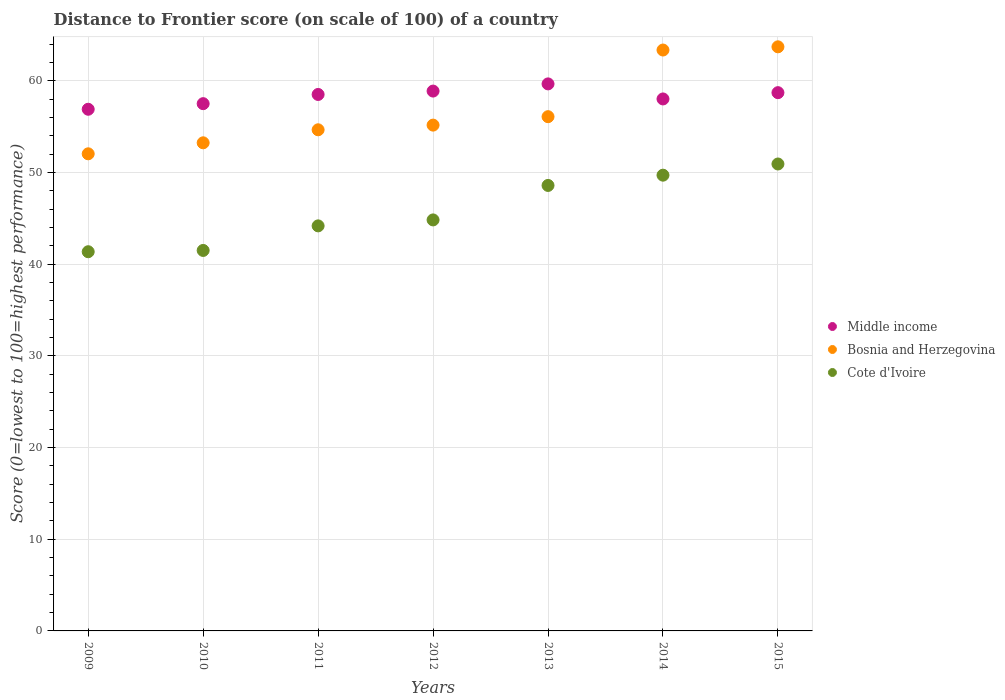Is the number of dotlines equal to the number of legend labels?
Provide a short and direct response. Yes. What is the distance to frontier score of in Middle income in 2010?
Keep it short and to the point. 57.51. Across all years, what is the maximum distance to frontier score of in Bosnia and Herzegovina?
Provide a succinct answer. 63.71. Across all years, what is the minimum distance to frontier score of in Middle income?
Your answer should be very brief. 56.9. In which year was the distance to frontier score of in Cote d'Ivoire maximum?
Provide a succinct answer. 2015. In which year was the distance to frontier score of in Middle income minimum?
Ensure brevity in your answer.  2009. What is the total distance to frontier score of in Cote d'Ivoire in the graph?
Offer a very short reply. 321.1. What is the difference between the distance to frontier score of in Middle income in 2009 and that in 2015?
Make the answer very short. -1.81. What is the difference between the distance to frontier score of in Cote d'Ivoire in 2015 and the distance to frontier score of in Bosnia and Herzegovina in 2013?
Your response must be concise. -5.16. What is the average distance to frontier score of in Middle income per year?
Make the answer very short. 58.32. What is the ratio of the distance to frontier score of in Bosnia and Herzegovina in 2010 to that in 2011?
Make the answer very short. 0.97. Is the difference between the distance to frontier score of in Cote d'Ivoire in 2009 and 2014 greater than the difference between the distance to frontier score of in Bosnia and Herzegovina in 2009 and 2014?
Offer a very short reply. Yes. What is the difference between the highest and the second highest distance to frontier score of in Cote d'Ivoire?
Your response must be concise. 1.22. What is the difference between the highest and the lowest distance to frontier score of in Cote d'Ivoire?
Make the answer very short. 9.57. In how many years, is the distance to frontier score of in Cote d'Ivoire greater than the average distance to frontier score of in Cote d'Ivoire taken over all years?
Give a very brief answer. 3. Is the sum of the distance to frontier score of in Cote d'Ivoire in 2009 and 2015 greater than the maximum distance to frontier score of in Bosnia and Herzegovina across all years?
Your response must be concise. Yes. Is it the case that in every year, the sum of the distance to frontier score of in Middle income and distance to frontier score of in Cote d'Ivoire  is greater than the distance to frontier score of in Bosnia and Herzegovina?
Your response must be concise. Yes. Is the distance to frontier score of in Middle income strictly greater than the distance to frontier score of in Bosnia and Herzegovina over the years?
Ensure brevity in your answer.  No. Is the distance to frontier score of in Middle income strictly less than the distance to frontier score of in Bosnia and Herzegovina over the years?
Ensure brevity in your answer.  No. How many dotlines are there?
Offer a terse response. 3. How many years are there in the graph?
Give a very brief answer. 7. What is the difference between two consecutive major ticks on the Y-axis?
Ensure brevity in your answer.  10. Does the graph contain any zero values?
Provide a short and direct response. No. Where does the legend appear in the graph?
Offer a very short reply. Center right. How many legend labels are there?
Ensure brevity in your answer.  3. What is the title of the graph?
Offer a very short reply. Distance to Frontier score (on scale of 100) of a country. What is the label or title of the X-axis?
Offer a very short reply. Years. What is the label or title of the Y-axis?
Provide a succinct answer. Score (0=lowest to 100=highest performance). What is the Score (0=lowest to 100=highest performance) in Middle income in 2009?
Keep it short and to the point. 56.9. What is the Score (0=lowest to 100=highest performance) in Bosnia and Herzegovina in 2009?
Offer a very short reply. 52.04. What is the Score (0=lowest to 100=highest performance) of Cote d'Ivoire in 2009?
Your response must be concise. 41.36. What is the Score (0=lowest to 100=highest performance) in Middle income in 2010?
Offer a terse response. 57.51. What is the Score (0=lowest to 100=highest performance) in Bosnia and Herzegovina in 2010?
Keep it short and to the point. 53.24. What is the Score (0=lowest to 100=highest performance) in Cote d'Ivoire in 2010?
Your response must be concise. 41.5. What is the Score (0=lowest to 100=highest performance) of Middle income in 2011?
Provide a succinct answer. 58.51. What is the Score (0=lowest to 100=highest performance) in Bosnia and Herzegovina in 2011?
Make the answer very short. 54.66. What is the Score (0=lowest to 100=highest performance) in Cote d'Ivoire in 2011?
Keep it short and to the point. 44.18. What is the Score (0=lowest to 100=highest performance) of Middle income in 2012?
Make the answer very short. 58.88. What is the Score (0=lowest to 100=highest performance) in Bosnia and Herzegovina in 2012?
Your answer should be very brief. 55.17. What is the Score (0=lowest to 100=highest performance) of Cote d'Ivoire in 2012?
Offer a terse response. 44.83. What is the Score (0=lowest to 100=highest performance) of Middle income in 2013?
Your answer should be very brief. 59.67. What is the Score (0=lowest to 100=highest performance) of Bosnia and Herzegovina in 2013?
Offer a terse response. 56.09. What is the Score (0=lowest to 100=highest performance) of Cote d'Ivoire in 2013?
Your answer should be compact. 48.59. What is the Score (0=lowest to 100=highest performance) of Middle income in 2014?
Keep it short and to the point. 58.02. What is the Score (0=lowest to 100=highest performance) of Bosnia and Herzegovina in 2014?
Keep it short and to the point. 63.36. What is the Score (0=lowest to 100=highest performance) in Cote d'Ivoire in 2014?
Provide a short and direct response. 49.71. What is the Score (0=lowest to 100=highest performance) of Middle income in 2015?
Ensure brevity in your answer.  58.71. What is the Score (0=lowest to 100=highest performance) of Bosnia and Herzegovina in 2015?
Offer a very short reply. 63.71. What is the Score (0=lowest to 100=highest performance) in Cote d'Ivoire in 2015?
Your response must be concise. 50.93. Across all years, what is the maximum Score (0=lowest to 100=highest performance) of Middle income?
Offer a very short reply. 59.67. Across all years, what is the maximum Score (0=lowest to 100=highest performance) of Bosnia and Herzegovina?
Offer a very short reply. 63.71. Across all years, what is the maximum Score (0=lowest to 100=highest performance) of Cote d'Ivoire?
Your answer should be very brief. 50.93. Across all years, what is the minimum Score (0=lowest to 100=highest performance) of Middle income?
Keep it short and to the point. 56.9. Across all years, what is the minimum Score (0=lowest to 100=highest performance) of Bosnia and Herzegovina?
Offer a very short reply. 52.04. Across all years, what is the minimum Score (0=lowest to 100=highest performance) of Cote d'Ivoire?
Offer a very short reply. 41.36. What is the total Score (0=lowest to 100=highest performance) in Middle income in the graph?
Give a very brief answer. 408.21. What is the total Score (0=lowest to 100=highest performance) of Bosnia and Herzegovina in the graph?
Your answer should be compact. 398.27. What is the total Score (0=lowest to 100=highest performance) of Cote d'Ivoire in the graph?
Offer a terse response. 321.1. What is the difference between the Score (0=lowest to 100=highest performance) of Middle income in 2009 and that in 2010?
Keep it short and to the point. -0.61. What is the difference between the Score (0=lowest to 100=highest performance) in Cote d'Ivoire in 2009 and that in 2010?
Offer a terse response. -0.14. What is the difference between the Score (0=lowest to 100=highest performance) of Middle income in 2009 and that in 2011?
Your answer should be very brief. -1.61. What is the difference between the Score (0=lowest to 100=highest performance) of Bosnia and Herzegovina in 2009 and that in 2011?
Provide a short and direct response. -2.62. What is the difference between the Score (0=lowest to 100=highest performance) of Cote d'Ivoire in 2009 and that in 2011?
Your answer should be very brief. -2.82. What is the difference between the Score (0=lowest to 100=highest performance) of Middle income in 2009 and that in 2012?
Offer a terse response. -1.98. What is the difference between the Score (0=lowest to 100=highest performance) in Bosnia and Herzegovina in 2009 and that in 2012?
Make the answer very short. -3.13. What is the difference between the Score (0=lowest to 100=highest performance) in Cote d'Ivoire in 2009 and that in 2012?
Ensure brevity in your answer.  -3.47. What is the difference between the Score (0=lowest to 100=highest performance) in Middle income in 2009 and that in 2013?
Keep it short and to the point. -2.77. What is the difference between the Score (0=lowest to 100=highest performance) of Bosnia and Herzegovina in 2009 and that in 2013?
Your answer should be compact. -4.05. What is the difference between the Score (0=lowest to 100=highest performance) in Cote d'Ivoire in 2009 and that in 2013?
Your answer should be very brief. -7.23. What is the difference between the Score (0=lowest to 100=highest performance) in Middle income in 2009 and that in 2014?
Keep it short and to the point. -1.12. What is the difference between the Score (0=lowest to 100=highest performance) of Bosnia and Herzegovina in 2009 and that in 2014?
Offer a very short reply. -11.32. What is the difference between the Score (0=lowest to 100=highest performance) in Cote d'Ivoire in 2009 and that in 2014?
Keep it short and to the point. -8.35. What is the difference between the Score (0=lowest to 100=highest performance) in Middle income in 2009 and that in 2015?
Offer a terse response. -1.81. What is the difference between the Score (0=lowest to 100=highest performance) in Bosnia and Herzegovina in 2009 and that in 2015?
Your answer should be compact. -11.67. What is the difference between the Score (0=lowest to 100=highest performance) in Cote d'Ivoire in 2009 and that in 2015?
Provide a short and direct response. -9.57. What is the difference between the Score (0=lowest to 100=highest performance) of Middle income in 2010 and that in 2011?
Offer a terse response. -1. What is the difference between the Score (0=lowest to 100=highest performance) in Bosnia and Herzegovina in 2010 and that in 2011?
Ensure brevity in your answer.  -1.42. What is the difference between the Score (0=lowest to 100=highest performance) of Cote d'Ivoire in 2010 and that in 2011?
Make the answer very short. -2.68. What is the difference between the Score (0=lowest to 100=highest performance) in Middle income in 2010 and that in 2012?
Offer a very short reply. -1.37. What is the difference between the Score (0=lowest to 100=highest performance) of Bosnia and Herzegovina in 2010 and that in 2012?
Provide a succinct answer. -1.93. What is the difference between the Score (0=lowest to 100=highest performance) of Cote d'Ivoire in 2010 and that in 2012?
Your answer should be very brief. -3.33. What is the difference between the Score (0=lowest to 100=highest performance) of Middle income in 2010 and that in 2013?
Make the answer very short. -2.16. What is the difference between the Score (0=lowest to 100=highest performance) in Bosnia and Herzegovina in 2010 and that in 2013?
Provide a short and direct response. -2.85. What is the difference between the Score (0=lowest to 100=highest performance) of Cote d'Ivoire in 2010 and that in 2013?
Ensure brevity in your answer.  -7.09. What is the difference between the Score (0=lowest to 100=highest performance) in Middle income in 2010 and that in 2014?
Give a very brief answer. -0.51. What is the difference between the Score (0=lowest to 100=highest performance) in Bosnia and Herzegovina in 2010 and that in 2014?
Offer a terse response. -10.12. What is the difference between the Score (0=lowest to 100=highest performance) in Cote d'Ivoire in 2010 and that in 2014?
Keep it short and to the point. -8.21. What is the difference between the Score (0=lowest to 100=highest performance) of Middle income in 2010 and that in 2015?
Ensure brevity in your answer.  -1.2. What is the difference between the Score (0=lowest to 100=highest performance) in Bosnia and Herzegovina in 2010 and that in 2015?
Your answer should be compact. -10.47. What is the difference between the Score (0=lowest to 100=highest performance) of Cote d'Ivoire in 2010 and that in 2015?
Keep it short and to the point. -9.43. What is the difference between the Score (0=lowest to 100=highest performance) in Middle income in 2011 and that in 2012?
Ensure brevity in your answer.  -0.37. What is the difference between the Score (0=lowest to 100=highest performance) of Bosnia and Herzegovina in 2011 and that in 2012?
Offer a very short reply. -0.51. What is the difference between the Score (0=lowest to 100=highest performance) in Cote d'Ivoire in 2011 and that in 2012?
Provide a short and direct response. -0.65. What is the difference between the Score (0=lowest to 100=highest performance) of Middle income in 2011 and that in 2013?
Your response must be concise. -1.15. What is the difference between the Score (0=lowest to 100=highest performance) of Bosnia and Herzegovina in 2011 and that in 2013?
Your answer should be very brief. -1.43. What is the difference between the Score (0=lowest to 100=highest performance) of Cote d'Ivoire in 2011 and that in 2013?
Give a very brief answer. -4.41. What is the difference between the Score (0=lowest to 100=highest performance) of Middle income in 2011 and that in 2014?
Make the answer very short. 0.49. What is the difference between the Score (0=lowest to 100=highest performance) of Cote d'Ivoire in 2011 and that in 2014?
Provide a short and direct response. -5.53. What is the difference between the Score (0=lowest to 100=highest performance) of Middle income in 2011 and that in 2015?
Ensure brevity in your answer.  -0.2. What is the difference between the Score (0=lowest to 100=highest performance) of Bosnia and Herzegovina in 2011 and that in 2015?
Your answer should be compact. -9.05. What is the difference between the Score (0=lowest to 100=highest performance) in Cote d'Ivoire in 2011 and that in 2015?
Provide a short and direct response. -6.75. What is the difference between the Score (0=lowest to 100=highest performance) of Middle income in 2012 and that in 2013?
Your response must be concise. -0.78. What is the difference between the Score (0=lowest to 100=highest performance) of Bosnia and Herzegovina in 2012 and that in 2013?
Your answer should be very brief. -0.92. What is the difference between the Score (0=lowest to 100=highest performance) of Cote d'Ivoire in 2012 and that in 2013?
Your answer should be very brief. -3.76. What is the difference between the Score (0=lowest to 100=highest performance) of Middle income in 2012 and that in 2014?
Ensure brevity in your answer.  0.86. What is the difference between the Score (0=lowest to 100=highest performance) in Bosnia and Herzegovina in 2012 and that in 2014?
Provide a succinct answer. -8.19. What is the difference between the Score (0=lowest to 100=highest performance) in Cote d'Ivoire in 2012 and that in 2014?
Provide a short and direct response. -4.88. What is the difference between the Score (0=lowest to 100=highest performance) in Middle income in 2012 and that in 2015?
Give a very brief answer. 0.17. What is the difference between the Score (0=lowest to 100=highest performance) of Bosnia and Herzegovina in 2012 and that in 2015?
Give a very brief answer. -8.54. What is the difference between the Score (0=lowest to 100=highest performance) of Middle income in 2013 and that in 2014?
Offer a very short reply. 1.64. What is the difference between the Score (0=lowest to 100=highest performance) in Bosnia and Herzegovina in 2013 and that in 2014?
Your answer should be compact. -7.27. What is the difference between the Score (0=lowest to 100=highest performance) of Cote d'Ivoire in 2013 and that in 2014?
Provide a succinct answer. -1.12. What is the difference between the Score (0=lowest to 100=highest performance) in Middle income in 2013 and that in 2015?
Keep it short and to the point. 0.96. What is the difference between the Score (0=lowest to 100=highest performance) of Bosnia and Herzegovina in 2013 and that in 2015?
Ensure brevity in your answer.  -7.62. What is the difference between the Score (0=lowest to 100=highest performance) of Cote d'Ivoire in 2013 and that in 2015?
Your answer should be compact. -2.34. What is the difference between the Score (0=lowest to 100=highest performance) of Middle income in 2014 and that in 2015?
Your answer should be compact. -0.69. What is the difference between the Score (0=lowest to 100=highest performance) in Bosnia and Herzegovina in 2014 and that in 2015?
Offer a very short reply. -0.35. What is the difference between the Score (0=lowest to 100=highest performance) in Cote d'Ivoire in 2014 and that in 2015?
Give a very brief answer. -1.22. What is the difference between the Score (0=lowest to 100=highest performance) of Middle income in 2009 and the Score (0=lowest to 100=highest performance) of Bosnia and Herzegovina in 2010?
Your answer should be very brief. 3.66. What is the difference between the Score (0=lowest to 100=highest performance) of Middle income in 2009 and the Score (0=lowest to 100=highest performance) of Cote d'Ivoire in 2010?
Make the answer very short. 15.4. What is the difference between the Score (0=lowest to 100=highest performance) in Bosnia and Herzegovina in 2009 and the Score (0=lowest to 100=highest performance) in Cote d'Ivoire in 2010?
Your response must be concise. 10.54. What is the difference between the Score (0=lowest to 100=highest performance) in Middle income in 2009 and the Score (0=lowest to 100=highest performance) in Bosnia and Herzegovina in 2011?
Your answer should be very brief. 2.24. What is the difference between the Score (0=lowest to 100=highest performance) of Middle income in 2009 and the Score (0=lowest to 100=highest performance) of Cote d'Ivoire in 2011?
Make the answer very short. 12.72. What is the difference between the Score (0=lowest to 100=highest performance) in Bosnia and Herzegovina in 2009 and the Score (0=lowest to 100=highest performance) in Cote d'Ivoire in 2011?
Offer a terse response. 7.86. What is the difference between the Score (0=lowest to 100=highest performance) in Middle income in 2009 and the Score (0=lowest to 100=highest performance) in Bosnia and Herzegovina in 2012?
Offer a terse response. 1.73. What is the difference between the Score (0=lowest to 100=highest performance) in Middle income in 2009 and the Score (0=lowest to 100=highest performance) in Cote d'Ivoire in 2012?
Ensure brevity in your answer.  12.07. What is the difference between the Score (0=lowest to 100=highest performance) in Bosnia and Herzegovina in 2009 and the Score (0=lowest to 100=highest performance) in Cote d'Ivoire in 2012?
Offer a terse response. 7.21. What is the difference between the Score (0=lowest to 100=highest performance) of Middle income in 2009 and the Score (0=lowest to 100=highest performance) of Bosnia and Herzegovina in 2013?
Your answer should be compact. 0.81. What is the difference between the Score (0=lowest to 100=highest performance) in Middle income in 2009 and the Score (0=lowest to 100=highest performance) in Cote d'Ivoire in 2013?
Your response must be concise. 8.31. What is the difference between the Score (0=lowest to 100=highest performance) of Bosnia and Herzegovina in 2009 and the Score (0=lowest to 100=highest performance) of Cote d'Ivoire in 2013?
Offer a very short reply. 3.45. What is the difference between the Score (0=lowest to 100=highest performance) in Middle income in 2009 and the Score (0=lowest to 100=highest performance) in Bosnia and Herzegovina in 2014?
Give a very brief answer. -6.46. What is the difference between the Score (0=lowest to 100=highest performance) of Middle income in 2009 and the Score (0=lowest to 100=highest performance) of Cote d'Ivoire in 2014?
Offer a terse response. 7.19. What is the difference between the Score (0=lowest to 100=highest performance) in Bosnia and Herzegovina in 2009 and the Score (0=lowest to 100=highest performance) in Cote d'Ivoire in 2014?
Provide a succinct answer. 2.33. What is the difference between the Score (0=lowest to 100=highest performance) of Middle income in 2009 and the Score (0=lowest to 100=highest performance) of Bosnia and Herzegovina in 2015?
Provide a short and direct response. -6.81. What is the difference between the Score (0=lowest to 100=highest performance) of Middle income in 2009 and the Score (0=lowest to 100=highest performance) of Cote d'Ivoire in 2015?
Keep it short and to the point. 5.97. What is the difference between the Score (0=lowest to 100=highest performance) of Bosnia and Herzegovina in 2009 and the Score (0=lowest to 100=highest performance) of Cote d'Ivoire in 2015?
Make the answer very short. 1.11. What is the difference between the Score (0=lowest to 100=highest performance) in Middle income in 2010 and the Score (0=lowest to 100=highest performance) in Bosnia and Herzegovina in 2011?
Give a very brief answer. 2.85. What is the difference between the Score (0=lowest to 100=highest performance) of Middle income in 2010 and the Score (0=lowest to 100=highest performance) of Cote d'Ivoire in 2011?
Provide a succinct answer. 13.33. What is the difference between the Score (0=lowest to 100=highest performance) in Bosnia and Herzegovina in 2010 and the Score (0=lowest to 100=highest performance) in Cote d'Ivoire in 2011?
Keep it short and to the point. 9.06. What is the difference between the Score (0=lowest to 100=highest performance) of Middle income in 2010 and the Score (0=lowest to 100=highest performance) of Bosnia and Herzegovina in 2012?
Ensure brevity in your answer.  2.34. What is the difference between the Score (0=lowest to 100=highest performance) of Middle income in 2010 and the Score (0=lowest to 100=highest performance) of Cote d'Ivoire in 2012?
Ensure brevity in your answer.  12.68. What is the difference between the Score (0=lowest to 100=highest performance) in Bosnia and Herzegovina in 2010 and the Score (0=lowest to 100=highest performance) in Cote d'Ivoire in 2012?
Your answer should be compact. 8.41. What is the difference between the Score (0=lowest to 100=highest performance) of Middle income in 2010 and the Score (0=lowest to 100=highest performance) of Bosnia and Herzegovina in 2013?
Offer a terse response. 1.42. What is the difference between the Score (0=lowest to 100=highest performance) of Middle income in 2010 and the Score (0=lowest to 100=highest performance) of Cote d'Ivoire in 2013?
Make the answer very short. 8.92. What is the difference between the Score (0=lowest to 100=highest performance) of Bosnia and Herzegovina in 2010 and the Score (0=lowest to 100=highest performance) of Cote d'Ivoire in 2013?
Provide a short and direct response. 4.65. What is the difference between the Score (0=lowest to 100=highest performance) of Middle income in 2010 and the Score (0=lowest to 100=highest performance) of Bosnia and Herzegovina in 2014?
Your answer should be very brief. -5.85. What is the difference between the Score (0=lowest to 100=highest performance) of Middle income in 2010 and the Score (0=lowest to 100=highest performance) of Cote d'Ivoire in 2014?
Your response must be concise. 7.8. What is the difference between the Score (0=lowest to 100=highest performance) in Bosnia and Herzegovina in 2010 and the Score (0=lowest to 100=highest performance) in Cote d'Ivoire in 2014?
Provide a short and direct response. 3.53. What is the difference between the Score (0=lowest to 100=highest performance) in Middle income in 2010 and the Score (0=lowest to 100=highest performance) in Bosnia and Herzegovina in 2015?
Make the answer very short. -6.2. What is the difference between the Score (0=lowest to 100=highest performance) in Middle income in 2010 and the Score (0=lowest to 100=highest performance) in Cote d'Ivoire in 2015?
Offer a very short reply. 6.58. What is the difference between the Score (0=lowest to 100=highest performance) of Bosnia and Herzegovina in 2010 and the Score (0=lowest to 100=highest performance) of Cote d'Ivoire in 2015?
Ensure brevity in your answer.  2.31. What is the difference between the Score (0=lowest to 100=highest performance) in Middle income in 2011 and the Score (0=lowest to 100=highest performance) in Bosnia and Herzegovina in 2012?
Ensure brevity in your answer.  3.34. What is the difference between the Score (0=lowest to 100=highest performance) in Middle income in 2011 and the Score (0=lowest to 100=highest performance) in Cote d'Ivoire in 2012?
Provide a short and direct response. 13.68. What is the difference between the Score (0=lowest to 100=highest performance) in Bosnia and Herzegovina in 2011 and the Score (0=lowest to 100=highest performance) in Cote d'Ivoire in 2012?
Make the answer very short. 9.83. What is the difference between the Score (0=lowest to 100=highest performance) in Middle income in 2011 and the Score (0=lowest to 100=highest performance) in Bosnia and Herzegovina in 2013?
Your answer should be compact. 2.42. What is the difference between the Score (0=lowest to 100=highest performance) in Middle income in 2011 and the Score (0=lowest to 100=highest performance) in Cote d'Ivoire in 2013?
Provide a short and direct response. 9.92. What is the difference between the Score (0=lowest to 100=highest performance) of Bosnia and Herzegovina in 2011 and the Score (0=lowest to 100=highest performance) of Cote d'Ivoire in 2013?
Your response must be concise. 6.07. What is the difference between the Score (0=lowest to 100=highest performance) of Middle income in 2011 and the Score (0=lowest to 100=highest performance) of Bosnia and Herzegovina in 2014?
Offer a very short reply. -4.85. What is the difference between the Score (0=lowest to 100=highest performance) of Middle income in 2011 and the Score (0=lowest to 100=highest performance) of Cote d'Ivoire in 2014?
Your answer should be very brief. 8.8. What is the difference between the Score (0=lowest to 100=highest performance) of Bosnia and Herzegovina in 2011 and the Score (0=lowest to 100=highest performance) of Cote d'Ivoire in 2014?
Give a very brief answer. 4.95. What is the difference between the Score (0=lowest to 100=highest performance) in Middle income in 2011 and the Score (0=lowest to 100=highest performance) in Bosnia and Herzegovina in 2015?
Keep it short and to the point. -5.2. What is the difference between the Score (0=lowest to 100=highest performance) of Middle income in 2011 and the Score (0=lowest to 100=highest performance) of Cote d'Ivoire in 2015?
Give a very brief answer. 7.58. What is the difference between the Score (0=lowest to 100=highest performance) in Bosnia and Herzegovina in 2011 and the Score (0=lowest to 100=highest performance) in Cote d'Ivoire in 2015?
Offer a terse response. 3.73. What is the difference between the Score (0=lowest to 100=highest performance) of Middle income in 2012 and the Score (0=lowest to 100=highest performance) of Bosnia and Herzegovina in 2013?
Your answer should be compact. 2.79. What is the difference between the Score (0=lowest to 100=highest performance) of Middle income in 2012 and the Score (0=lowest to 100=highest performance) of Cote d'Ivoire in 2013?
Offer a very short reply. 10.29. What is the difference between the Score (0=lowest to 100=highest performance) in Bosnia and Herzegovina in 2012 and the Score (0=lowest to 100=highest performance) in Cote d'Ivoire in 2013?
Ensure brevity in your answer.  6.58. What is the difference between the Score (0=lowest to 100=highest performance) of Middle income in 2012 and the Score (0=lowest to 100=highest performance) of Bosnia and Herzegovina in 2014?
Ensure brevity in your answer.  -4.48. What is the difference between the Score (0=lowest to 100=highest performance) of Middle income in 2012 and the Score (0=lowest to 100=highest performance) of Cote d'Ivoire in 2014?
Offer a very short reply. 9.17. What is the difference between the Score (0=lowest to 100=highest performance) of Bosnia and Herzegovina in 2012 and the Score (0=lowest to 100=highest performance) of Cote d'Ivoire in 2014?
Provide a succinct answer. 5.46. What is the difference between the Score (0=lowest to 100=highest performance) in Middle income in 2012 and the Score (0=lowest to 100=highest performance) in Bosnia and Herzegovina in 2015?
Provide a short and direct response. -4.83. What is the difference between the Score (0=lowest to 100=highest performance) of Middle income in 2012 and the Score (0=lowest to 100=highest performance) of Cote d'Ivoire in 2015?
Your answer should be compact. 7.95. What is the difference between the Score (0=lowest to 100=highest performance) in Bosnia and Herzegovina in 2012 and the Score (0=lowest to 100=highest performance) in Cote d'Ivoire in 2015?
Ensure brevity in your answer.  4.24. What is the difference between the Score (0=lowest to 100=highest performance) of Middle income in 2013 and the Score (0=lowest to 100=highest performance) of Bosnia and Herzegovina in 2014?
Give a very brief answer. -3.69. What is the difference between the Score (0=lowest to 100=highest performance) in Middle income in 2013 and the Score (0=lowest to 100=highest performance) in Cote d'Ivoire in 2014?
Offer a terse response. 9.96. What is the difference between the Score (0=lowest to 100=highest performance) of Bosnia and Herzegovina in 2013 and the Score (0=lowest to 100=highest performance) of Cote d'Ivoire in 2014?
Your answer should be compact. 6.38. What is the difference between the Score (0=lowest to 100=highest performance) of Middle income in 2013 and the Score (0=lowest to 100=highest performance) of Bosnia and Herzegovina in 2015?
Provide a succinct answer. -4.04. What is the difference between the Score (0=lowest to 100=highest performance) in Middle income in 2013 and the Score (0=lowest to 100=highest performance) in Cote d'Ivoire in 2015?
Offer a very short reply. 8.74. What is the difference between the Score (0=lowest to 100=highest performance) of Bosnia and Herzegovina in 2013 and the Score (0=lowest to 100=highest performance) of Cote d'Ivoire in 2015?
Ensure brevity in your answer.  5.16. What is the difference between the Score (0=lowest to 100=highest performance) of Middle income in 2014 and the Score (0=lowest to 100=highest performance) of Bosnia and Herzegovina in 2015?
Make the answer very short. -5.69. What is the difference between the Score (0=lowest to 100=highest performance) in Middle income in 2014 and the Score (0=lowest to 100=highest performance) in Cote d'Ivoire in 2015?
Your response must be concise. 7.09. What is the difference between the Score (0=lowest to 100=highest performance) of Bosnia and Herzegovina in 2014 and the Score (0=lowest to 100=highest performance) of Cote d'Ivoire in 2015?
Offer a terse response. 12.43. What is the average Score (0=lowest to 100=highest performance) in Middle income per year?
Offer a terse response. 58.32. What is the average Score (0=lowest to 100=highest performance) in Bosnia and Herzegovina per year?
Ensure brevity in your answer.  56.9. What is the average Score (0=lowest to 100=highest performance) in Cote d'Ivoire per year?
Your answer should be compact. 45.87. In the year 2009, what is the difference between the Score (0=lowest to 100=highest performance) of Middle income and Score (0=lowest to 100=highest performance) of Bosnia and Herzegovina?
Offer a very short reply. 4.86. In the year 2009, what is the difference between the Score (0=lowest to 100=highest performance) in Middle income and Score (0=lowest to 100=highest performance) in Cote d'Ivoire?
Offer a terse response. 15.54. In the year 2009, what is the difference between the Score (0=lowest to 100=highest performance) in Bosnia and Herzegovina and Score (0=lowest to 100=highest performance) in Cote d'Ivoire?
Your answer should be very brief. 10.68. In the year 2010, what is the difference between the Score (0=lowest to 100=highest performance) of Middle income and Score (0=lowest to 100=highest performance) of Bosnia and Herzegovina?
Your answer should be compact. 4.27. In the year 2010, what is the difference between the Score (0=lowest to 100=highest performance) in Middle income and Score (0=lowest to 100=highest performance) in Cote d'Ivoire?
Provide a succinct answer. 16.01. In the year 2010, what is the difference between the Score (0=lowest to 100=highest performance) of Bosnia and Herzegovina and Score (0=lowest to 100=highest performance) of Cote d'Ivoire?
Offer a very short reply. 11.74. In the year 2011, what is the difference between the Score (0=lowest to 100=highest performance) of Middle income and Score (0=lowest to 100=highest performance) of Bosnia and Herzegovina?
Your answer should be very brief. 3.85. In the year 2011, what is the difference between the Score (0=lowest to 100=highest performance) in Middle income and Score (0=lowest to 100=highest performance) in Cote d'Ivoire?
Your answer should be compact. 14.33. In the year 2011, what is the difference between the Score (0=lowest to 100=highest performance) in Bosnia and Herzegovina and Score (0=lowest to 100=highest performance) in Cote d'Ivoire?
Ensure brevity in your answer.  10.48. In the year 2012, what is the difference between the Score (0=lowest to 100=highest performance) in Middle income and Score (0=lowest to 100=highest performance) in Bosnia and Herzegovina?
Provide a short and direct response. 3.71. In the year 2012, what is the difference between the Score (0=lowest to 100=highest performance) in Middle income and Score (0=lowest to 100=highest performance) in Cote d'Ivoire?
Give a very brief answer. 14.05. In the year 2012, what is the difference between the Score (0=lowest to 100=highest performance) of Bosnia and Herzegovina and Score (0=lowest to 100=highest performance) of Cote d'Ivoire?
Offer a very short reply. 10.34. In the year 2013, what is the difference between the Score (0=lowest to 100=highest performance) of Middle income and Score (0=lowest to 100=highest performance) of Bosnia and Herzegovina?
Make the answer very short. 3.58. In the year 2013, what is the difference between the Score (0=lowest to 100=highest performance) of Middle income and Score (0=lowest to 100=highest performance) of Cote d'Ivoire?
Your answer should be very brief. 11.08. In the year 2014, what is the difference between the Score (0=lowest to 100=highest performance) in Middle income and Score (0=lowest to 100=highest performance) in Bosnia and Herzegovina?
Ensure brevity in your answer.  -5.34. In the year 2014, what is the difference between the Score (0=lowest to 100=highest performance) in Middle income and Score (0=lowest to 100=highest performance) in Cote d'Ivoire?
Your answer should be compact. 8.31. In the year 2014, what is the difference between the Score (0=lowest to 100=highest performance) of Bosnia and Herzegovina and Score (0=lowest to 100=highest performance) of Cote d'Ivoire?
Provide a succinct answer. 13.65. In the year 2015, what is the difference between the Score (0=lowest to 100=highest performance) in Middle income and Score (0=lowest to 100=highest performance) in Bosnia and Herzegovina?
Offer a very short reply. -5. In the year 2015, what is the difference between the Score (0=lowest to 100=highest performance) of Middle income and Score (0=lowest to 100=highest performance) of Cote d'Ivoire?
Make the answer very short. 7.78. In the year 2015, what is the difference between the Score (0=lowest to 100=highest performance) in Bosnia and Herzegovina and Score (0=lowest to 100=highest performance) in Cote d'Ivoire?
Provide a succinct answer. 12.78. What is the ratio of the Score (0=lowest to 100=highest performance) in Bosnia and Herzegovina in 2009 to that in 2010?
Your response must be concise. 0.98. What is the ratio of the Score (0=lowest to 100=highest performance) in Middle income in 2009 to that in 2011?
Offer a very short reply. 0.97. What is the ratio of the Score (0=lowest to 100=highest performance) in Bosnia and Herzegovina in 2009 to that in 2011?
Give a very brief answer. 0.95. What is the ratio of the Score (0=lowest to 100=highest performance) of Cote d'Ivoire in 2009 to that in 2011?
Keep it short and to the point. 0.94. What is the ratio of the Score (0=lowest to 100=highest performance) of Middle income in 2009 to that in 2012?
Keep it short and to the point. 0.97. What is the ratio of the Score (0=lowest to 100=highest performance) of Bosnia and Herzegovina in 2009 to that in 2012?
Make the answer very short. 0.94. What is the ratio of the Score (0=lowest to 100=highest performance) in Cote d'Ivoire in 2009 to that in 2012?
Make the answer very short. 0.92. What is the ratio of the Score (0=lowest to 100=highest performance) of Middle income in 2009 to that in 2013?
Your response must be concise. 0.95. What is the ratio of the Score (0=lowest to 100=highest performance) in Bosnia and Herzegovina in 2009 to that in 2013?
Ensure brevity in your answer.  0.93. What is the ratio of the Score (0=lowest to 100=highest performance) in Cote d'Ivoire in 2009 to that in 2013?
Your answer should be compact. 0.85. What is the ratio of the Score (0=lowest to 100=highest performance) in Middle income in 2009 to that in 2014?
Your answer should be compact. 0.98. What is the ratio of the Score (0=lowest to 100=highest performance) of Bosnia and Herzegovina in 2009 to that in 2014?
Your answer should be very brief. 0.82. What is the ratio of the Score (0=lowest to 100=highest performance) in Cote d'Ivoire in 2009 to that in 2014?
Provide a succinct answer. 0.83. What is the ratio of the Score (0=lowest to 100=highest performance) of Middle income in 2009 to that in 2015?
Offer a terse response. 0.97. What is the ratio of the Score (0=lowest to 100=highest performance) of Bosnia and Herzegovina in 2009 to that in 2015?
Offer a very short reply. 0.82. What is the ratio of the Score (0=lowest to 100=highest performance) of Cote d'Ivoire in 2009 to that in 2015?
Give a very brief answer. 0.81. What is the ratio of the Score (0=lowest to 100=highest performance) of Middle income in 2010 to that in 2011?
Keep it short and to the point. 0.98. What is the ratio of the Score (0=lowest to 100=highest performance) in Bosnia and Herzegovina in 2010 to that in 2011?
Your response must be concise. 0.97. What is the ratio of the Score (0=lowest to 100=highest performance) of Cote d'Ivoire in 2010 to that in 2011?
Offer a terse response. 0.94. What is the ratio of the Score (0=lowest to 100=highest performance) in Middle income in 2010 to that in 2012?
Offer a terse response. 0.98. What is the ratio of the Score (0=lowest to 100=highest performance) in Bosnia and Herzegovina in 2010 to that in 2012?
Provide a short and direct response. 0.96. What is the ratio of the Score (0=lowest to 100=highest performance) in Cote d'Ivoire in 2010 to that in 2012?
Provide a short and direct response. 0.93. What is the ratio of the Score (0=lowest to 100=highest performance) in Middle income in 2010 to that in 2013?
Offer a very short reply. 0.96. What is the ratio of the Score (0=lowest to 100=highest performance) in Bosnia and Herzegovina in 2010 to that in 2013?
Your answer should be compact. 0.95. What is the ratio of the Score (0=lowest to 100=highest performance) of Cote d'Ivoire in 2010 to that in 2013?
Keep it short and to the point. 0.85. What is the ratio of the Score (0=lowest to 100=highest performance) in Bosnia and Herzegovina in 2010 to that in 2014?
Offer a very short reply. 0.84. What is the ratio of the Score (0=lowest to 100=highest performance) in Cote d'Ivoire in 2010 to that in 2014?
Provide a succinct answer. 0.83. What is the ratio of the Score (0=lowest to 100=highest performance) of Middle income in 2010 to that in 2015?
Keep it short and to the point. 0.98. What is the ratio of the Score (0=lowest to 100=highest performance) of Bosnia and Herzegovina in 2010 to that in 2015?
Your answer should be compact. 0.84. What is the ratio of the Score (0=lowest to 100=highest performance) in Cote d'Ivoire in 2010 to that in 2015?
Give a very brief answer. 0.81. What is the ratio of the Score (0=lowest to 100=highest performance) in Middle income in 2011 to that in 2012?
Offer a terse response. 0.99. What is the ratio of the Score (0=lowest to 100=highest performance) in Bosnia and Herzegovina in 2011 to that in 2012?
Keep it short and to the point. 0.99. What is the ratio of the Score (0=lowest to 100=highest performance) in Cote d'Ivoire in 2011 to that in 2012?
Ensure brevity in your answer.  0.99. What is the ratio of the Score (0=lowest to 100=highest performance) in Middle income in 2011 to that in 2013?
Offer a very short reply. 0.98. What is the ratio of the Score (0=lowest to 100=highest performance) in Bosnia and Herzegovina in 2011 to that in 2013?
Make the answer very short. 0.97. What is the ratio of the Score (0=lowest to 100=highest performance) of Cote d'Ivoire in 2011 to that in 2013?
Your response must be concise. 0.91. What is the ratio of the Score (0=lowest to 100=highest performance) in Middle income in 2011 to that in 2014?
Give a very brief answer. 1.01. What is the ratio of the Score (0=lowest to 100=highest performance) in Bosnia and Herzegovina in 2011 to that in 2014?
Your answer should be very brief. 0.86. What is the ratio of the Score (0=lowest to 100=highest performance) in Cote d'Ivoire in 2011 to that in 2014?
Provide a succinct answer. 0.89. What is the ratio of the Score (0=lowest to 100=highest performance) in Bosnia and Herzegovina in 2011 to that in 2015?
Give a very brief answer. 0.86. What is the ratio of the Score (0=lowest to 100=highest performance) of Cote d'Ivoire in 2011 to that in 2015?
Your answer should be very brief. 0.87. What is the ratio of the Score (0=lowest to 100=highest performance) of Middle income in 2012 to that in 2013?
Ensure brevity in your answer.  0.99. What is the ratio of the Score (0=lowest to 100=highest performance) of Bosnia and Herzegovina in 2012 to that in 2013?
Your answer should be compact. 0.98. What is the ratio of the Score (0=lowest to 100=highest performance) of Cote d'Ivoire in 2012 to that in 2013?
Offer a very short reply. 0.92. What is the ratio of the Score (0=lowest to 100=highest performance) in Middle income in 2012 to that in 2014?
Your response must be concise. 1.01. What is the ratio of the Score (0=lowest to 100=highest performance) of Bosnia and Herzegovina in 2012 to that in 2014?
Keep it short and to the point. 0.87. What is the ratio of the Score (0=lowest to 100=highest performance) in Cote d'Ivoire in 2012 to that in 2014?
Ensure brevity in your answer.  0.9. What is the ratio of the Score (0=lowest to 100=highest performance) of Middle income in 2012 to that in 2015?
Provide a short and direct response. 1. What is the ratio of the Score (0=lowest to 100=highest performance) of Bosnia and Herzegovina in 2012 to that in 2015?
Keep it short and to the point. 0.87. What is the ratio of the Score (0=lowest to 100=highest performance) in Cote d'Ivoire in 2012 to that in 2015?
Offer a very short reply. 0.88. What is the ratio of the Score (0=lowest to 100=highest performance) in Middle income in 2013 to that in 2014?
Your answer should be very brief. 1.03. What is the ratio of the Score (0=lowest to 100=highest performance) of Bosnia and Herzegovina in 2013 to that in 2014?
Offer a terse response. 0.89. What is the ratio of the Score (0=lowest to 100=highest performance) in Cote d'Ivoire in 2013 to that in 2014?
Ensure brevity in your answer.  0.98. What is the ratio of the Score (0=lowest to 100=highest performance) of Middle income in 2013 to that in 2015?
Keep it short and to the point. 1.02. What is the ratio of the Score (0=lowest to 100=highest performance) of Bosnia and Herzegovina in 2013 to that in 2015?
Your answer should be compact. 0.88. What is the ratio of the Score (0=lowest to 100=highest performance) in Cote d'Ivoire in 2013 to that in 2015?
Offer a terse response. 0.95. What is the ratio of the Score (0=lowest to 100=highest performance) of Middle income in 2014 to that in 2015?
Keep it short and to the point. 0.99. What is the ratio of the Score (0=lowest to 100=highest performance) of Bosnia and Herzegovina in 2014 to that in 2015?
Your answer should be very brief. 0.99. What is the difference between the highest and the second highest Score (0=lowest to 100=highest performance) of Middle income?
Provide a succinct answer. 0.78. What is the difference between the highest and the second highest Score (0=lowest to 100=highest performance) in Cote d'Ivoire?
Your response must be concise. 1.22. What is the difference between the highest and the lowest Score (0=lowest to 100=highest performance) of Middle income?
Your answer should be compact. 2.77. What is the difference between the highest and the lowest Score (0=lowest to 100=highest performance) of Bosnia and Herzegovina?
Make the answer very short. 11.67. What is the difference between the highest and the lowest Score (0=lowest to 100=highest performance) of Cote d'Ivoire?
Make the answer very short. 9.57. 